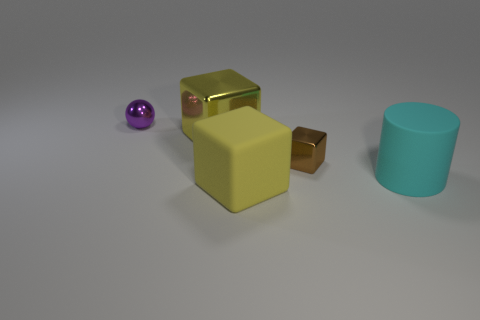What size is the shiny cube that is to the left of the yellow block that is in front of the small metal object in front of the small purple sphere?
Ensure brevity in your answer.  Large. Do the yellow shiny thing and the yellow thing in front of the small block have the same shape?
Your answer should be very brief. Yes. What number of other things are the same size as the yellow rubber thing?
Provide a succinct answer. 2. What size is the yellow block in front of the large rubber cylinder?
Ensure brevity in your answer.  Large. What number of blocks have the same material as the cyan object?
Your response must be concise. 1. There is a big yellow thing that is in front of the cyan matte cylinder; does it have the same shape as the cyan object?
Offer a very short reply. No. The brown metal thing that is to the left of the matte cylinder has what shape?
Your answer should be compact. Cube. What material is the small sphere?
Your answer should be compact. Metal. There is another shiny object that is the same size as the purple shiny object; what color is it?
Provide a short and direct response. Brown. The other object that is the same color as the big metal thing is what shape?
Give a very brief answer. Cube. 